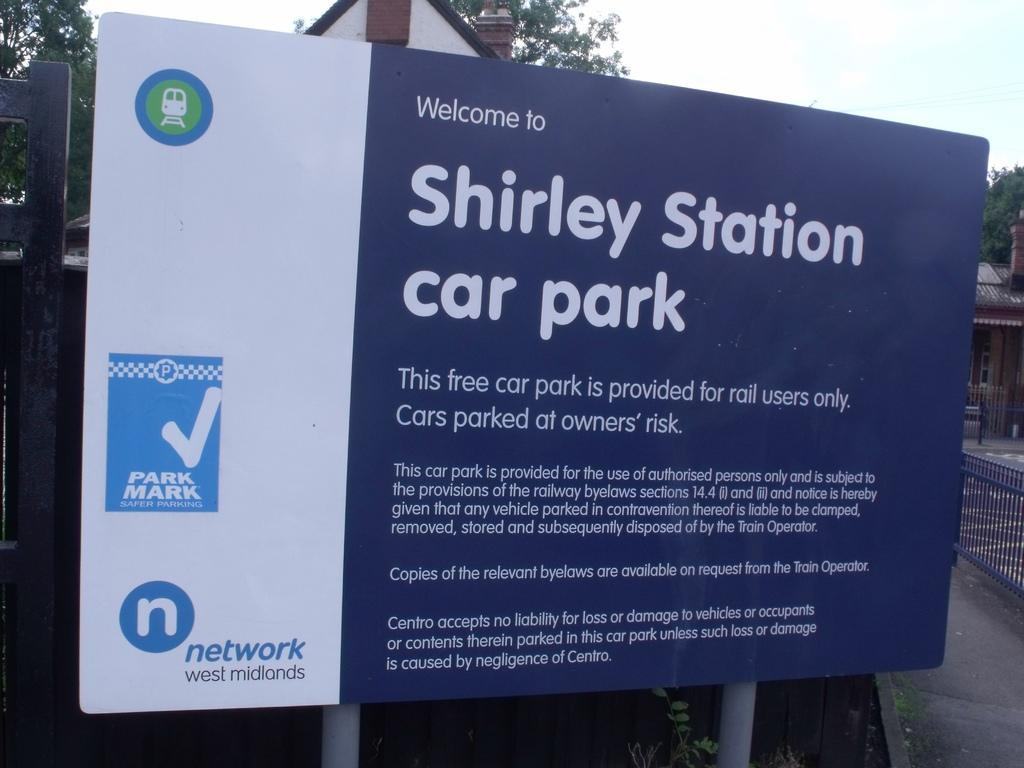<image>
Describe the image concisely. A large blue and white sign welcomes people to Shirley Station car park. 